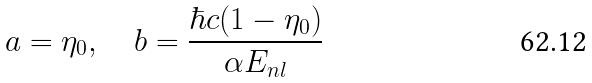Convert formula to latex. <formula><loc_0><loc_0><loc_500><loc_500>a = \eta _ { 0 } , \quad b = \frac { \hbar { c } ( 1 - \eta _ { 0 } ) } { \alpha E _ { n l } }</formula> 